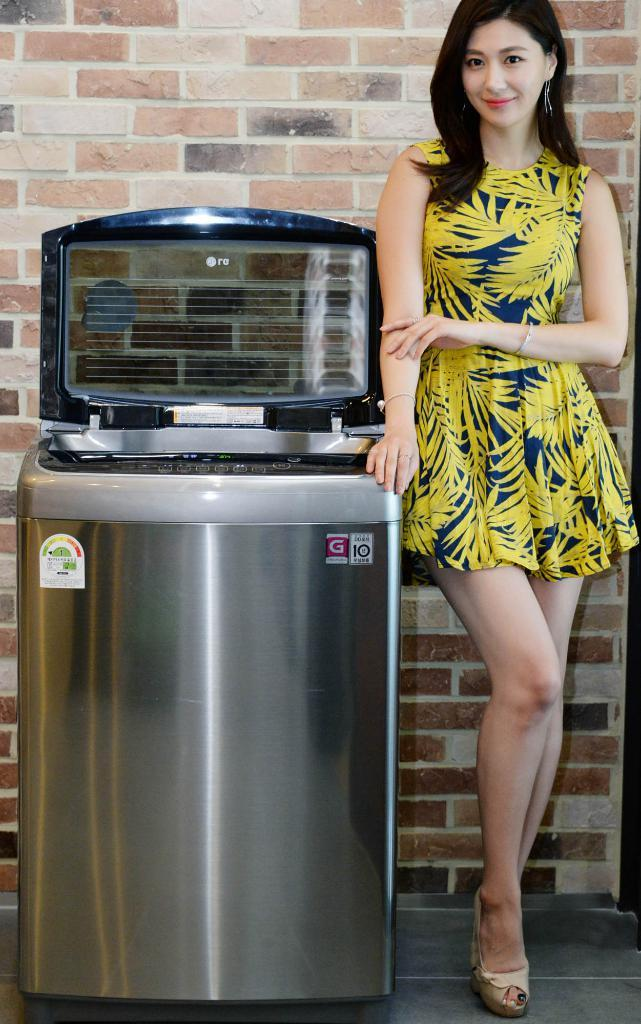What appliance can be seen in the image? There is a washing machine in the image. Who is present in the image besides the washing machine? There is a lady standing on the right side of the image. What is the lady's facial expression? The lady is smiling. What can be seen in the background of the image? There is a wall in the background of the image. What type of bike is leaning against the wall in the image? There is no bike present in the image; it only features a washing machine and a lady. 